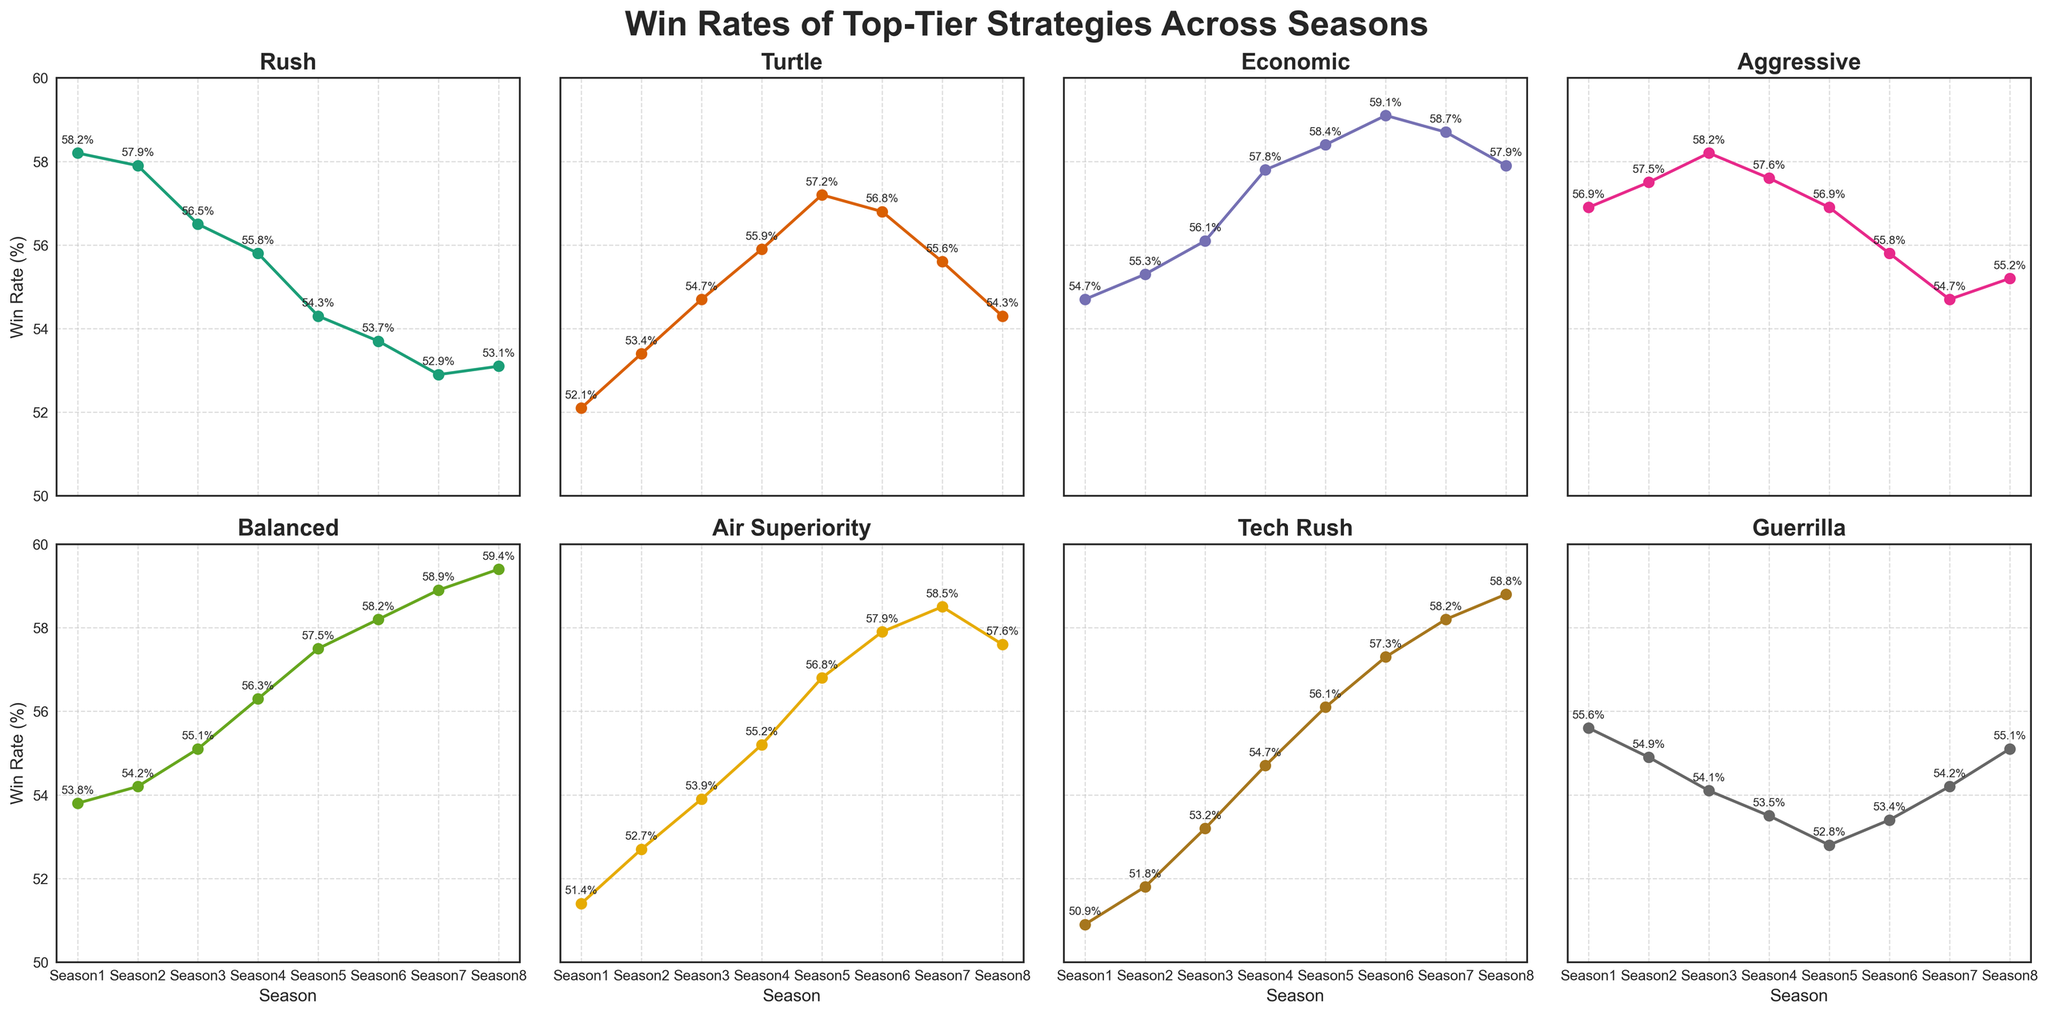Which strategy had the highest win rate in Season 5? To find the highest win rate in Season 5, compare the end points of all lines for Season 5. The Economic strategy has the highest win rate at 58.4%.
Answer: Economic Which strategies had a win rate increase from Season 1 to Season 8? To determine which strategies had an increase, compare the win rates in Season 1 and Season 8. Turtle, Economic, Balanced, Air Superiority, and Tech Rush all show an increase in their win rates.
Answer: Turtle, Economic, Balanced, Air Superiority, Tech Rush What is the greatest decrease in win rate across any two consecutive seasons? By examining the dip in the lines between any two consecutive seasons, the largest drop is the Rush strategy between Season 7 and Season 8 with a decrease from 52.9% to 53.1%.
Answer: 0.2 Comparing the Ends, Meta Trend: Which strategy had the smallest fluctuation in win rate from Season 1 to Season 8? Calculate the absolute change in win rates from Season 1 to Season 8 for each strategy. The Rush strategy fluctuates from 58.2% to 53.1%, giving a net change of 5.1%, the smallest among all strategies.
Answer: Rush Which strategy showed the most significant overall improvement from Season 2 to Season 6? To find the most improved strategy, compare win rates from Season 2 to Season 6 for each strategy. Tech Rush shows an increase from 51.8% to 57.3%, the largest improvement.
Answer: Tech Rush How many strategies had a peak win rate above 57%? For each strategy, identify the maximum value in their win rate curves. Rush, Economic, Aggressive, Balanced, Air Superiority, and Tech Rush all exceed 57% at their peaks.
Answer: 6 Are there any strategies with a consistent increase every season? Compare the win rates season by season for each strategy. Both Balanced and Tech Rush show a consistent increase each season without any drops.
Answer: Balanced, Tech Rush Which strategy had the steepest decline in win rate initially and did it recover? Focus on Season 1 to Season 2 data and look for the most significant drop. Rush shows a steep decline from 58.2% to 57.9%, but slightly recovers to 53.1% by Season 8.
Answer: Rush, yes Which strategy's performance had the most variability? To determine variability, look at the visual structure of the lines. Aggressive shows significant ups and downs, indicating high variability.
Answer: Aggressive 